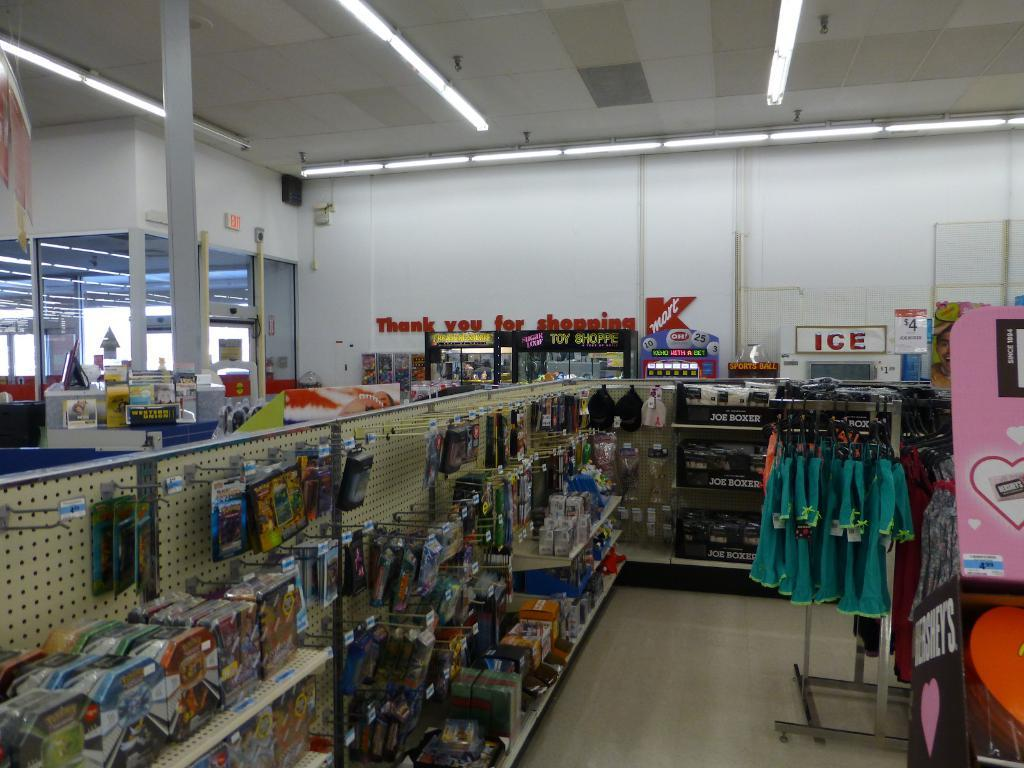<image>
Share a concise interpretation of the image provided. The word ICE is visible at the back of a store 